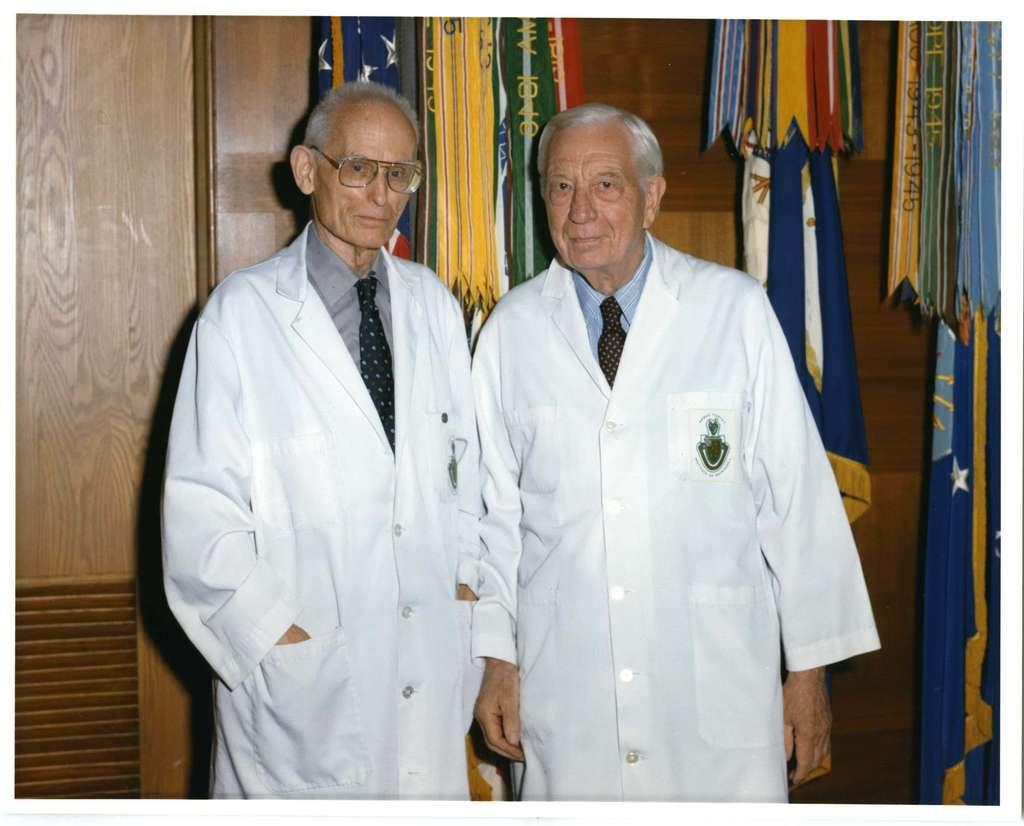How many people are in the image? There are two persons in the image. What are the persons wearing on their upper bodies? Both persons are wearing shirts and ties. What else are the persons wearing? Both persons are wearing aprons. What can be seen in the image besides the persons? There are flags visible in the image. Where are the flags placed in the image? The flags are placed near a wooden wall. What type of meal is being prepared in the image? There is no indication of a meal being prepared in the image. What level of difficulty is the show being performed at in the image? There is no show or performance taking place in the image. 